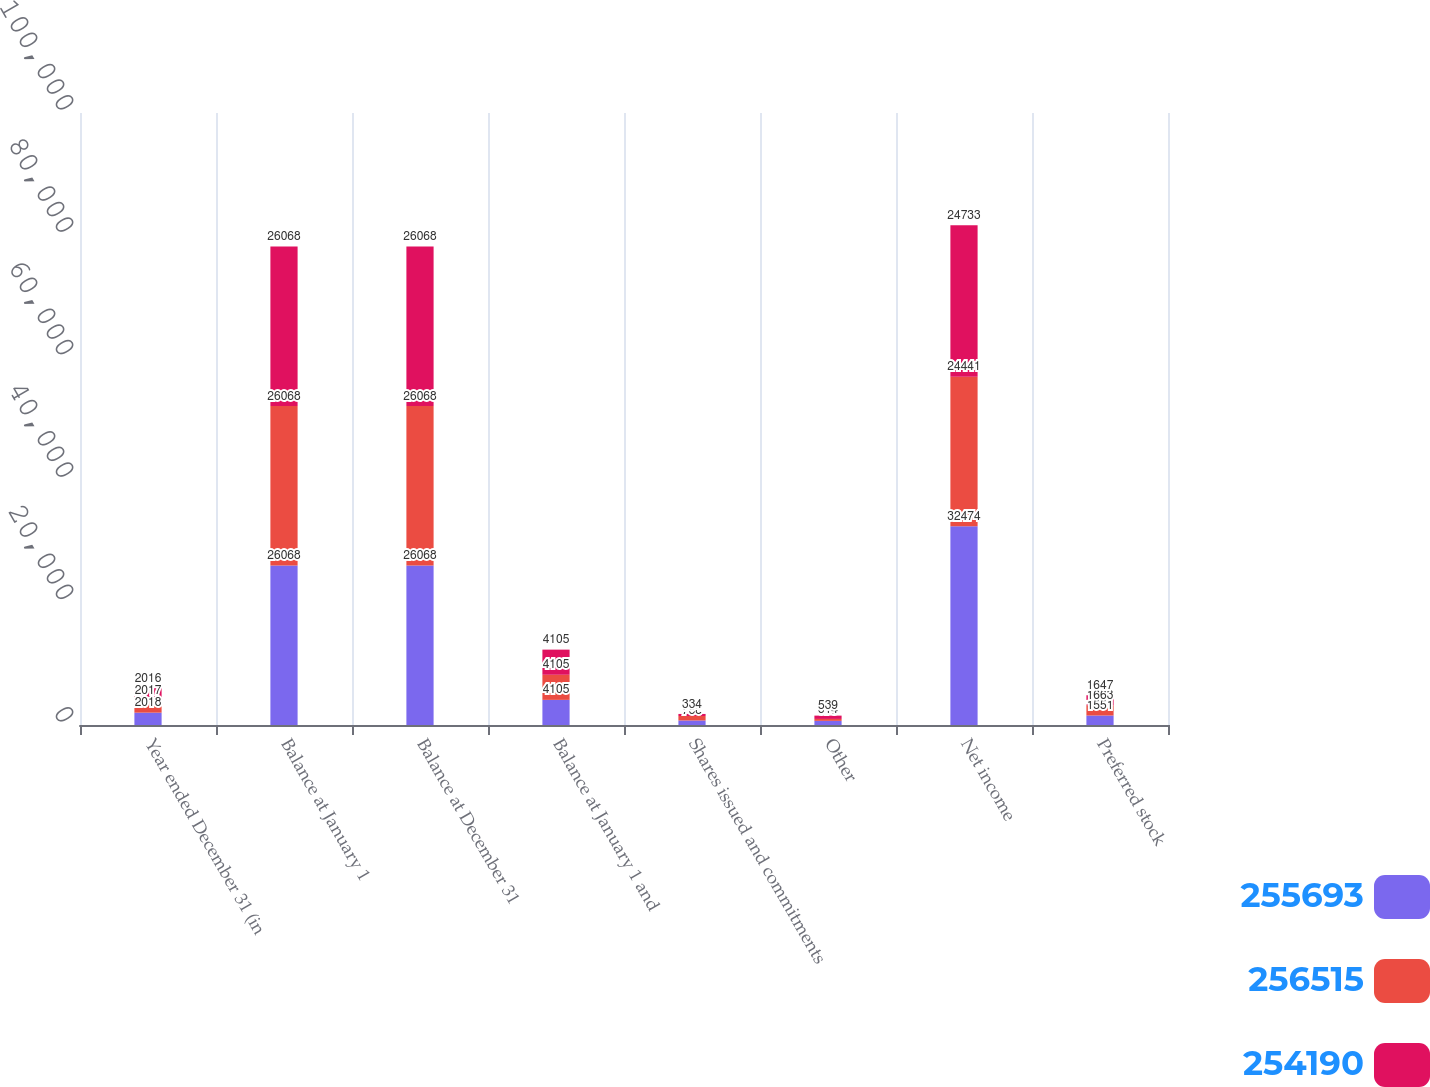Convert chart to OTSL. <chart><loc_0><loc_0><loc_500><loc_500><stacked_bar_chart><ecel><fcel>Year ended December 31 (in<fcel>Balance at January 1<fcel>Balance at December 31<fcel>Balance at January 1 and<fcel>Shares issued and commitments<fcel>Other<fcel>Net income<fcel>Preferred stock<nl><fcel>255693<fcel>2018<fcel>26068<fcel>26068<fcel>4105<fcel>738<fcel>679<fcel>32474<fcel>1551<nl><fcel>256515<fcel>2017<fcel>26068<fcel>26068<fcel>4105<fcel>734<fcel>314<fcel>24441<fcel>1663<nl><fcel>254190<fcel>2016<fcel>26068<fcel>26068<fcel>4105<fcel>334<fcel>539<fcel>24733<fcel>1647<nl></chart> 